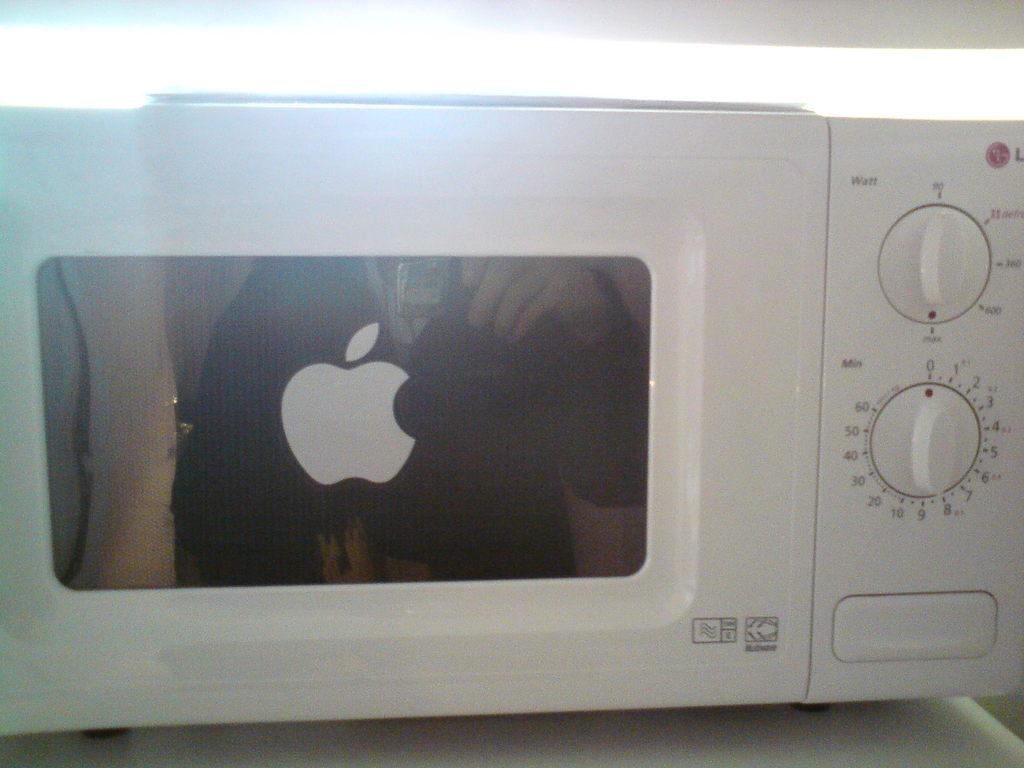What is the bottom dial set to?
Your response must be concise. 0. 